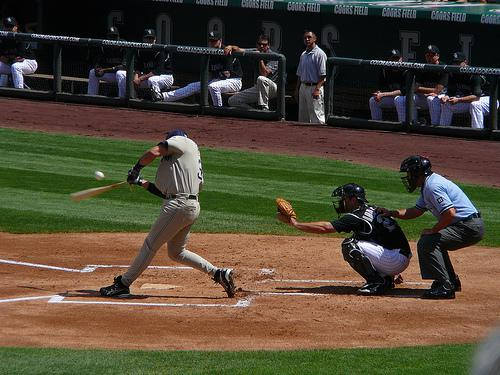Question: how many black helmets are there?
Choices:
A. Two.
B. One.
C. Three.
D. Four.
Answer with the letter. Answer: A Question: what color are the helmets?
Choices:
A. Black.
B. Red.
C. Silver.
D. Gold.
Answer with the letter. Answer: A Question: where was the photo taken?
Choices:
A. Baseball game.
B. Tennis match.
C. Playground.
D. Concert.
Answer with the letter. Answer: A 